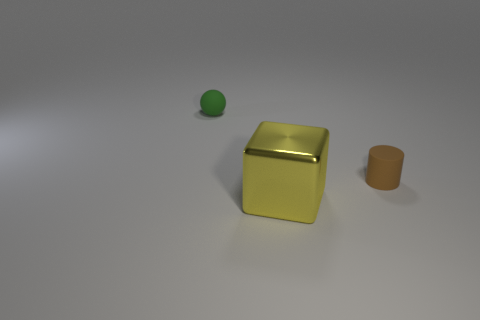Is there anything else that has the same material as the yellow block?
Provide a short and direct response. No. Do the big object and the ball have the same material?
Give a very brief answer. No. There is a brown thing that is the same size as the sphere; what is its material?
Provide a succinct answer. Rubber. What number of red metallic blocks are there?
Offer a very short reply. 0. There is a rubber sphere that is the same size as the brown cylinder; what is its color?
Give a very brief answer. Green. Are the object on the left side of the yellow metal thing and the object that is in front of the tiny brown cylinder made of the same material?
Offer a very short reply. No. How big is the thing in front of the tiny cylinder that is to the right of the yellow metal block?
Make the answer very short. Large. There is a tiny object that is to the right of the small green matte thing; what is it made of?
Offer a terse response. Rubber. How many things are tiny rubber things that are right of the large yellow block or tiny things left of the large thing?
Keep it short and to the point. 2. Is there a green ball of the same size as the brown thing?
Give a very brief answer. Yes. 